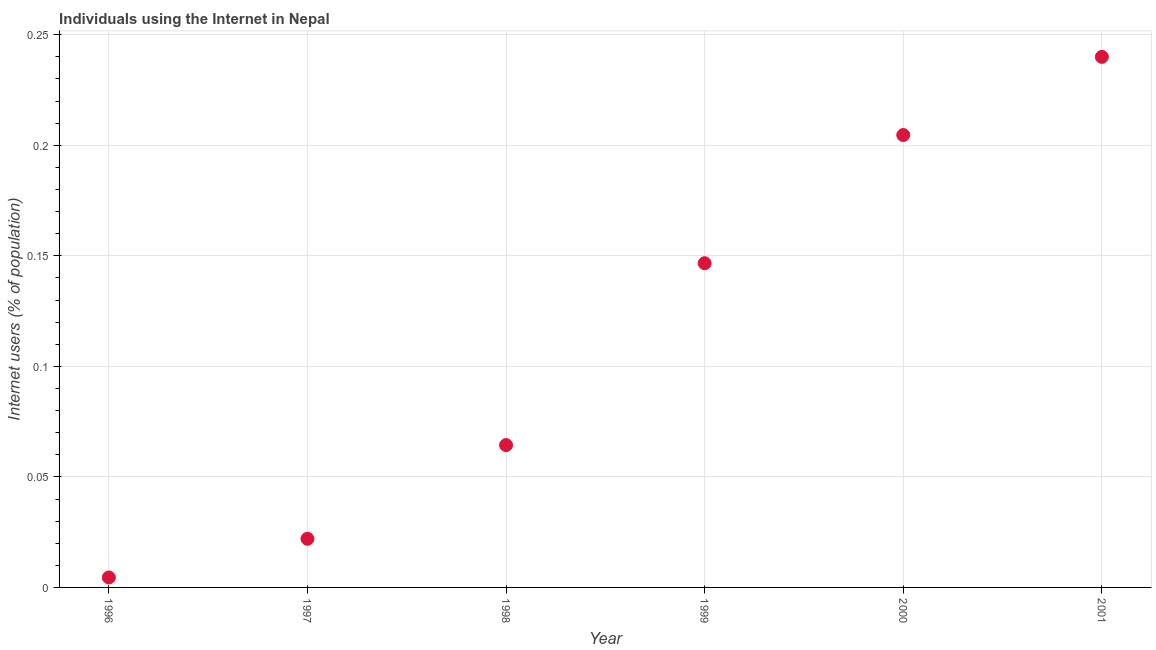What is the number of internet users in 1998?
Provide a short and direct response. 0.06. Across all years, what is the maximum number of internet users?
Make the answer very short. 0.24. Across all years, what is the minimum number of internet users?
Provide a succinct answer. 0. In which year was the number of internet users minimum?
Your response must be concise. 1996. What is the sum of the number of internet users?
Your answer should be very brief. 0.68. What is the difference between the number of internet users in 1998 and 1999?
Ensure brevity in your answer.  -0.08. What is the average number of internet users per year?
Offer a very short reply. 0.11. What is the median number of internet users?
Your answer should be very brief. 0.11. Do a majority of the years between 2000 and 1997 (inclusive) have number of internet users greater than 0.13 %?
Make the answer very short. Yes. What is the ratio of the number of internet users in 1997 to that in 1998?
Provide a short and direct response. 0.34. Is the number of internet users in 1999 less than that in 2000?
Make the answer very short. Yes. Is the difference between the number of internet users in 1997 and 1998 greater than the difference between any two years?
Offer a very short reply. No. What is the difference between the highest and the second highest number of internet users?
Your answer should be very brief. 0.04. Is the sum of the number of internet users in 1997 and 1998 greater than the maximum number of internet users across all years?
Provide a succinct answer. No. What is the difference between the highest and the lowest number of internet users?
Offer a very short reply. 0.24. Does the number of internet users monotonically increase over the years?
Your response must be concise. Yes. How many dotlines are there?
Your answer should be compact. 1. How many years are there in the graph?
Your answer should be compact. 6. What is the difference between two consecutive major ticks on the Y-axis?
Make the answer very short. 0.05. Are the values on the major ticks of Y-axis written in scientific E-notation?
Offer a very short reply. No. What is the title of the graph?
Your response must be concise. Individuals using the Internet in Nepal. What is the label or title of the X-axis?
Make the answer very short. Year. What is the label or title of the Y-axis?
Offer a very short reply. Internet users (% of population). What is the Internet users (% of population) in 1996?
Keep it short and to the point. 0. What is the Internet users (% of population) in 1997?
Offer a very short reply. 0.02. What is the Internet users (% of population) in 1998?
Your answer should be compact. 0.06. What is the Internet users (% of population) in 1999?
Your response must be concise. 0.15. What is the Internet users (% of population) in 2000?
Give a very brief answer. 0.2. What is the Internet users (% of population) in 2001?
Ensure brevity in your answer.  0.24. What is the difference between the Internet users (% of population) in 1996 and 1997?
Keep it short and to the point. -0.02. What is the difference between the Internet users (% of population) in 1996 and 1998?
Offer a very short reply. -0.06. What is the difference between the Internet users (% of population) in 1996 and 1999?
Offer a very short reply. -0.14. What is the difference between the Internet users (% of population) in 1996 and 2000?
Make the answer very short. -0.2. What is the difference between the Internet users (% of population) in 1996 and 2001?
Ensure brevity in your answer.  -0.24. What is the difference between the Internet users (% of population) in 1997 and 1998?
Your answer should be very brief. -0.04. What is the difference between the Internet users (% of population) in 1997 and 1999?
Make the answer very short. -0.12. What is the difference between the Internet users (% of population) in 1997 and 2000?
Ensure brevity in your answer.  -0.18. What is the difference between the Internet users (% of population) in 1997 and 2001?
Give a very brief answer. -0.22. What is the difference between the Internet users (% of population) in 1998 and 1999?
Provide a short and direct response. -0.08. What is the difference between the Internet users (% of population) in 1998 and 2000?
Your answer should be very brief. -0.14. What is the difference between the Internet users (% of population) in 1998 and 2001?
Give a very brief answer. -0.18. What is the difference between the Internet users (% of population) in 1999 and 2000?
Give a very brief answer. -0.06. What is the difference between the Internet users (% of population) in 1999 and 2001?
Offer a terse response. -0.09. What is the difference between the Internet users (% of population) in 2000 and 2001?
Ensure brevity in your answer.  -0.04. What is the ratio of the Internet users (% of population) in 1996 to that in 1997?
Make the answer very short. 0.2. What is the ratio of the Internet users (% of population) in 1996 to that in 1998?
Provide a succinct answer. 0.07. What is the ratio of the Internet users (% of population) in 1996 to that in 1999?
Offer a very short reply. 0.03. What is the ratio of the Internet users (% of population) in 1996 to that in 2000?
Make the answer very short. 0.02. What is the ratio of the Internet users (% of population) in 1996 to that in 2001?
Your answer should be very brief. 0.02. What is the ratio of the Internet users (% of population) in 1997 to that in 1998?
Offer a terse response. 0.34. What is the ratio of the Internet users (% of population) in 1997 to that in 2000?
Keep it short and to the point. 0.11. What is the ratio of the Internet users (% of population) in 1997 to that in 2001?
Your answer should be very brief. 0.09. What is the ratio of the Internet users (% of population) in 1998 to that in 1999?
Provide a succinct answer. 0.44. What is the ratio of the Internet users (% of population) in 1998 to that in 2000?
Your answer should be compact. 0.32. What is the ratio of the Internet users (% of population) in 1998 to that in 2001?
Your answer should be very brief. 0.27. What is the ratio of the Internet users (% of population) in 1999 to that in 2000?
Your response must be concise. 0.72. What is the ratio of the Internet users (% of population) in 1999 to that in 2001?
Keep it short and to the point. 0.61. What is the ratio of the Internet users (% of population) in 2000 to that in 2001?
Your response must be concise. 0.85. 